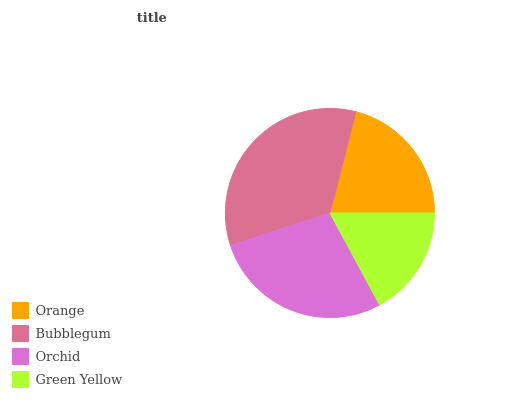Is Green Yellow the minimum?
Answer yes or no. Yes. Is Bubblegum the maximum?
Answer yes or no. Yes. Is Orchid the minimum?
Answer yes or no. No. Is Orchid the maximum?
Answer yes or no. No. Is Bubblegum greater than Orchid?
Answer yes or no. Yes. Is Orchid less than Bubblegum?
Answer yes or no. Yes. Is Orchid greater than Bubblegum?
Answer yes or no. No. Is Bubblegum less than Orchid?
Answer yes or no. No. Is Orchid the high median?
Answer yes or no. Yes. Is Orange the low median?
Answer yes or no. Yes. Is Green Yellow the high median?
Answer yes or no. No. Is Orchid the low median?
Answer yes or no. No. 